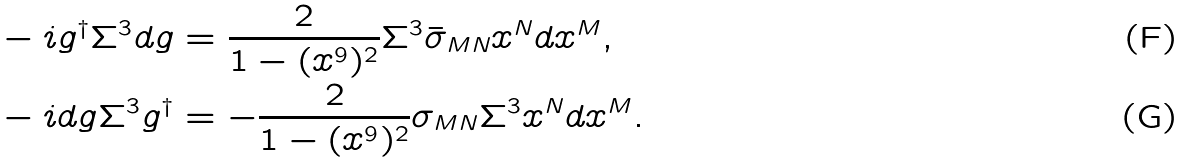Convert formula to latex. <formula><loc_0><loc_0><loc_500><loc_500>& - i g ^ { \dagger } \Sigma ^ { 3 } d g = \frac { 2 } { 1 - ( x ^ { 9 } ) ^ { 2 } } \Sigma ^ { 3 } \bar { \sigma } _ { M N } x ^ { N } d x ^ { M } , \\ & - i d g \Sigma ^ { 3 } g ^ { \dagger } = - \frac { 2 } { 1 - ( x ^ { 9 } ) ^ { 2 } } \sigma _ { M N } \Sigma ^ { 3 } x ^ { N } d x ^ { M } .</formula> 